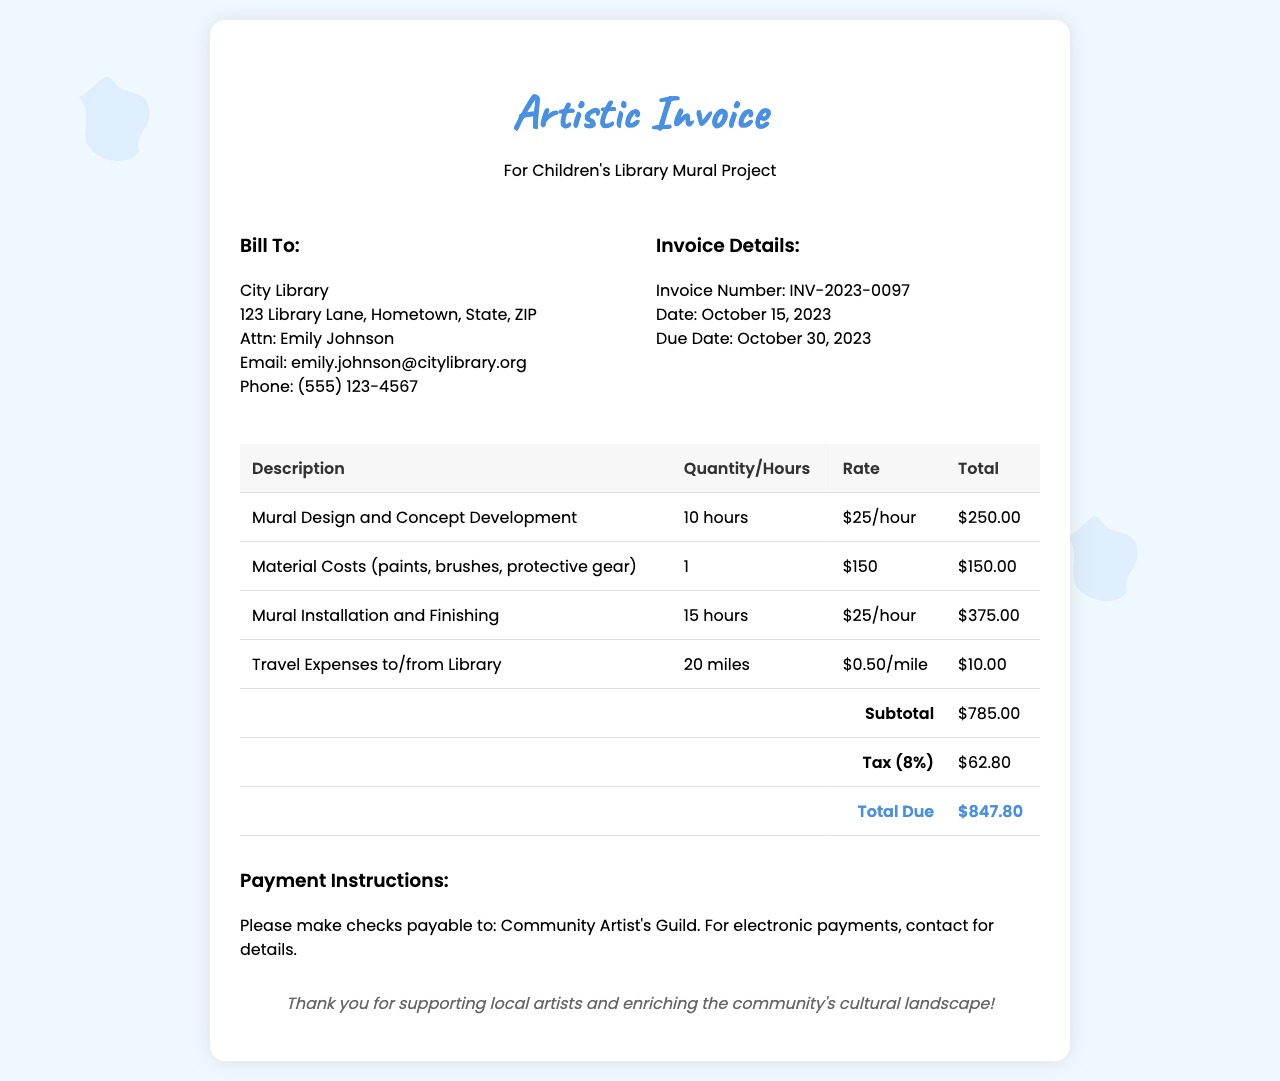What is the invoice number? The invoice number is a unique identifier for this specific invoice, which is listed in the document.
Answer: INV-2023-0097 What is the due date of the invoice? The due date refers to when the full payment is expected and is specified in the document.
Answer: October 30, 2023 Who is the invoice addressed to? The recipient of the invoice is specified in the "Bill To" section of the document.
Answer: City Library What is the total amount due? The document states the total amount due, which is the final figure after all calculations.
Answer: $847.80 How many hours were spent on mural design and concept development? The number of hours dedicated to this specific task is highlighted in the invoice items.
Answer: 10 hours What percentage is used for tax calculation? The tax rate applied to the subtotal is explicitly mentioned in the document.
Answer: 8% What are the payment instructions? The document outlines how payments should be made, detailing the payment options available.
Answer: Please make checks payable to: Community Artist's Guild What were the travel expenses to/from the library? Travel costs are documented separately and indicate the number of miles traveled along with the rate.
Answer: $10.00 What was the rate charged per hour for mural installation? The rate for a specific service is specified next to that service in the invoice.
Answer: $25/hour 